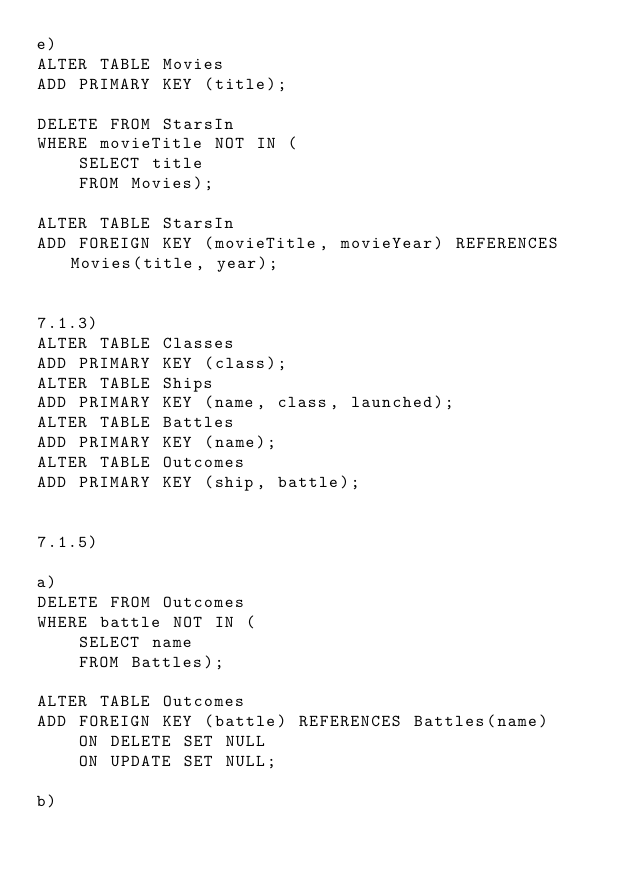<code> <loc_0><loc_0><loc_500><loc_500><_SQL_>e)
ALTER TABLE Movies 
ADD PRIMARY KEY (title);

DELETE FROM StarsIn
WHERE movieTitle NOT IN (
	SELECT title
	FROM Movies);

ALTER TABLE StarsIn
ADD FOREIGN KEY (movieTitle, movieYear) REFERENCES Movies(title, year);


7.1.3)
ALTER TABLE Classes 
ADD PRIMARY KEY (class);
ALTER TABLE Ships
ADD PRIMARY KEY (name, class, launched);
ALTER TABLE Battles
ADD PRIMARY KEY (name);
ALTER TABLE Outcomes
ADD PRIMARY KEY (ship, battle);


7.1.5)

a)
DELETE FROM Outcomes
WHERE battle NOT IN (
	SELECT name
	FROM Battles);

ALTER TABLE Outcomes
ADD FOREIGN KEY (battle) REFERENCES Battles(name)
	ON DELETE SET NULL
	ON UPDATE SET NULL;

b)</code> 